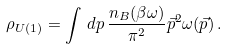Convert formula to latex. <formula><loc_0><loc_0><loc_500><loc_500>\rho _ { U ( 1 ) } = \int \, d p \, \frac { n _ { B } ( \beta \omega ) } { \pi ^ { 2 } } \vec { p } ^ { 2 } \omega ( \vec { p } ) \, .</formula> 